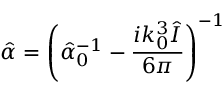Convert formula to latex. <formula><loc_0><loc_0><loc_500><loc_500>\hat { \alpha } = \left ( \hat { \alpha } _ { 0 } ^ { - 1 } - \frac { i k _ { 0 } ^ { 3 } \hat { I } } { 6 \pi } \right ) ^ { - 1 }</formula> 